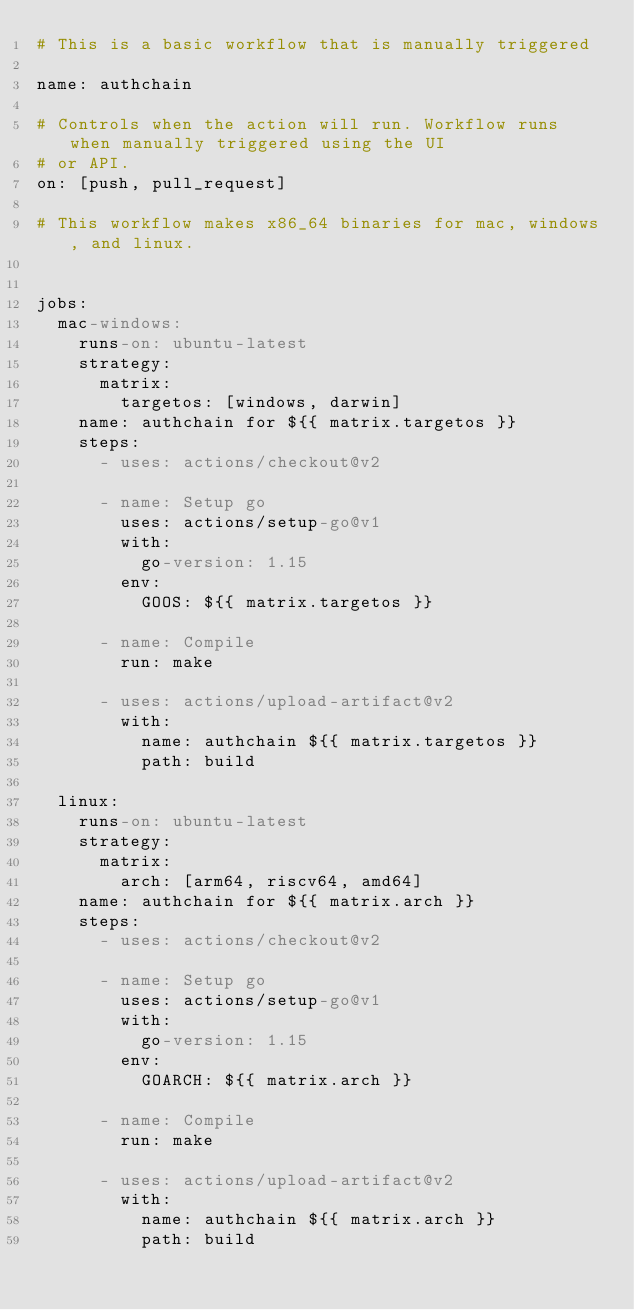Convert code to text. <code><loc_0><loc_0><loc_500><loc_500><_YAML_># This is a basic workflow that is manually triggered

name: authchain

# Controls when the action will run. Workflow runs when manually triggered using the UI
# or API.
on: [push, pull_request]

# This workflow makes x86_64 binaries for mac, windows, and linux.


jobs:
  mac-windows:
    runs-on: ubuntu-latest
    strategy:
      matrix:
        targetos: [windows, darwin]
    name: authchain for ${{ matrix.targetos }}
    steps:
      - uses: actions/checkout@v2

      - name: Setup go
        uses: actions/setup-go@v1
        with:
          go-version: 1.15
        env:
          GOOS: ${{ matrix.targetos }}

      - name: Compile
        run: make

      - uses: actions/upload-artifact@v2
        with:
          name: authchain ${{ matrix.targetos }}
          path: build

  linux:
    runs-on: ubuntu-latest
    strategy:
      matrix:
        arch: [arm64, riscv64, amd64]
    name: authchain for ${{ matrix.arch }}
    steps:
      - uses: actions/checkout@v2

      - name: Setup go
        uses: actions/setup-go@v1
        with:
          go-version: 1.15
        env:
          GOARCH: ${{ matrix.arch }}

      - name: Compile
        run: make

      - uses: actions/upload-artifact@v2
        with:
          name: authchain ${{ matrix.arch }}
          path: build
</code> 